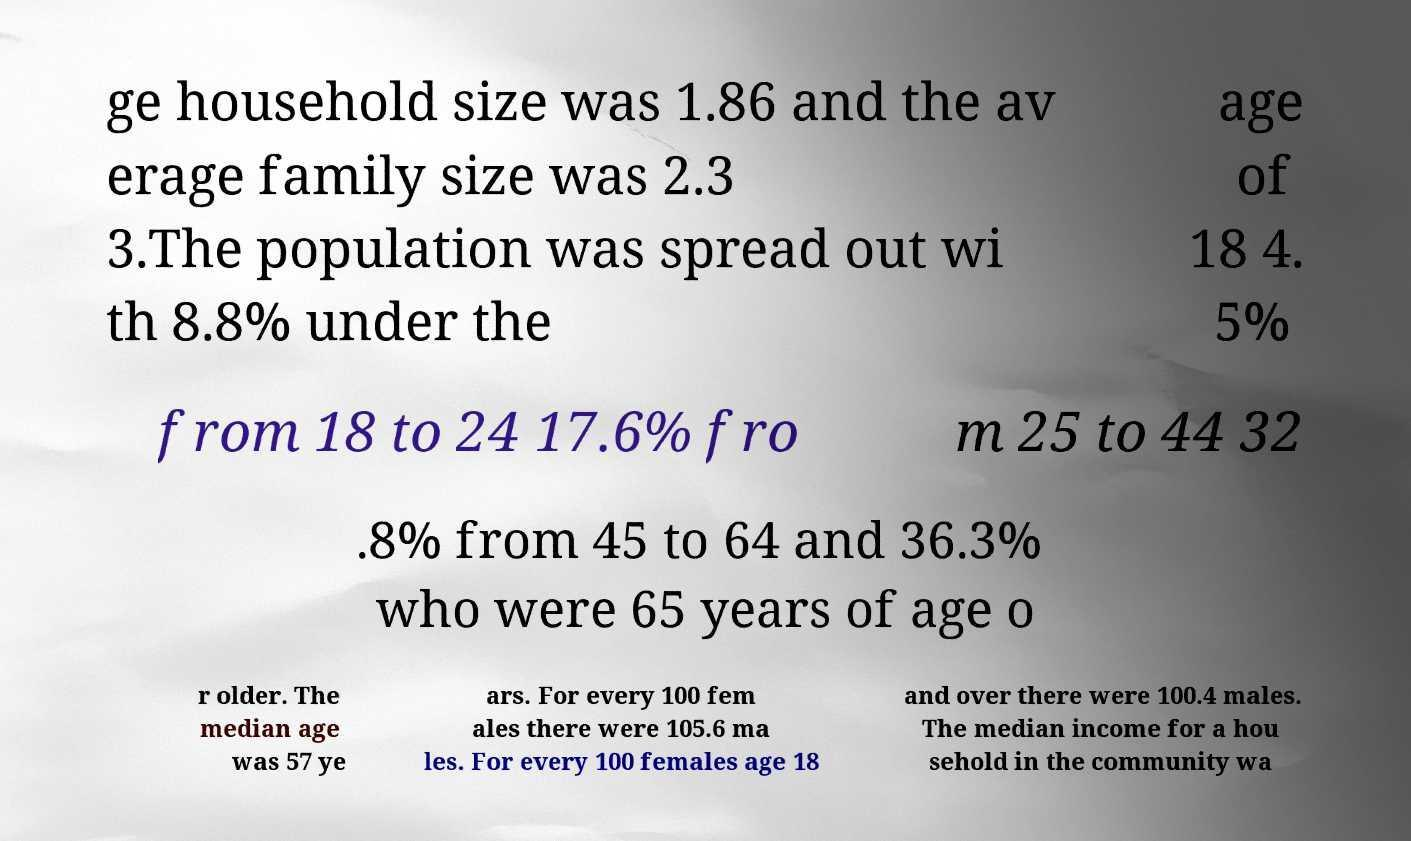I need the written content from this picture converted into text. Can you do that? ge household size was 1.86 and the av erage family size was 2.3 3.The population was spread out wi th 8.8% under the age of 18 4. 5% from 18 to 24 17.6% fro m 25 to 44 32 .8% from 45 to 64 and 36.3% who were 65 years of age o r older. The median age was 57 ye ars. For every 100 fem ales there were 105.6 ma les. For every 100 females age 18 and over there were 100.4 males. The median income for a hou sehold in the community wa 